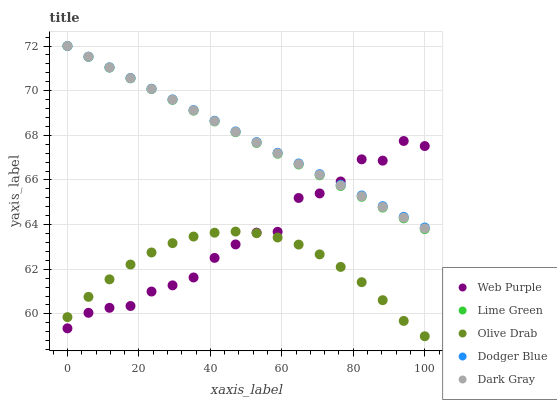Does Olive Drab have the minimum area under the curve?
Answer yes or no. Yes. Does Dodger Blue have the maximum area under the curve?
Answer yes or no. Yes. Does Web Purple have the minimum area under the curve?
Answer yes or no. No. Does Web Purple have the maximum area under the curve?
Answer yes or no. No. Is Dark Gray the smoothest?
Answer yes or no. Yes. Is Web Purple the roughest?
Answer yes or no. Yes. Is Dodger Blue the smoothest?
Answer yes or no. No. Is Dodger Blue the roughest?
Answer yes or no. No. Does Olive Drab have the lowest value?
Answer yes or no. Yes. Does Web Purple have the lowest value?
Answer yes or no. No. Does Lime Green have the highest value?
Answer yes or no. Yes. Does Web Purple have the highest value?
Answer yes or no. No. Is Olive Drab less than Dodger Blue?
Answer yes or no. Yes. Is Dark Gray greater than Olive Drab?
Answer yes or no. Yes. Does Lime Green intersect Dodger Blue?
Answer yes or no. Yes. Is Lime Green less than Dodger Blue?
Answer yes or no. No. Is Lime Green greater than Dodger Blue?
Answer yes or no. No. Does Olive Drab intersect Dodger Blue?
Answer yes or no. No. 